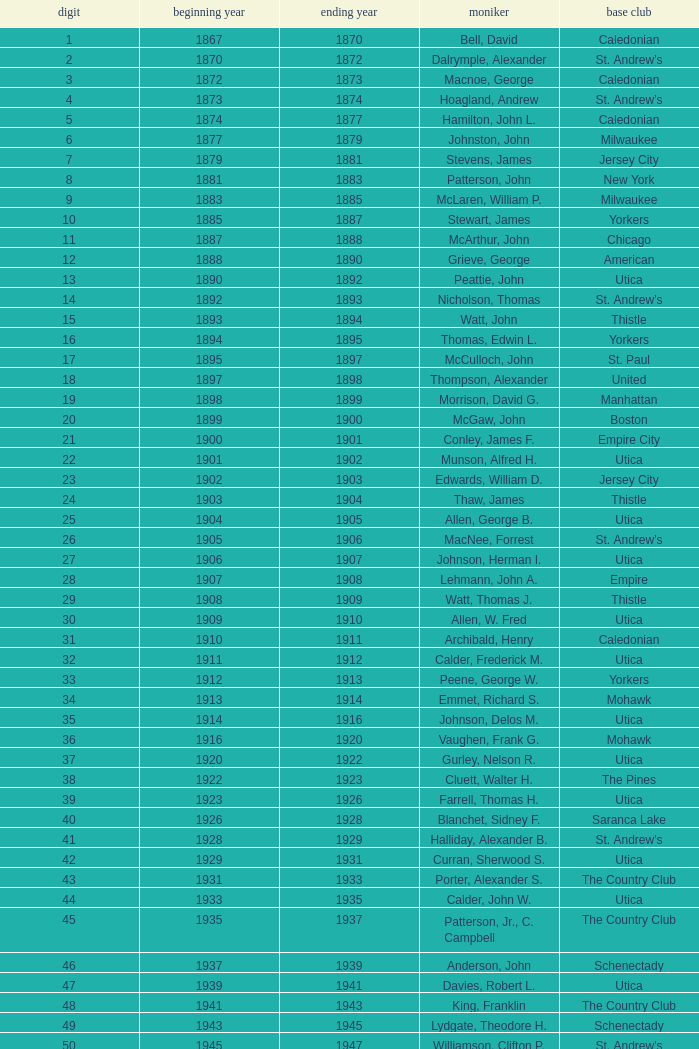Which Number has a Name of cooper, c. kenneth, and a Year End larger than 1984? None. 